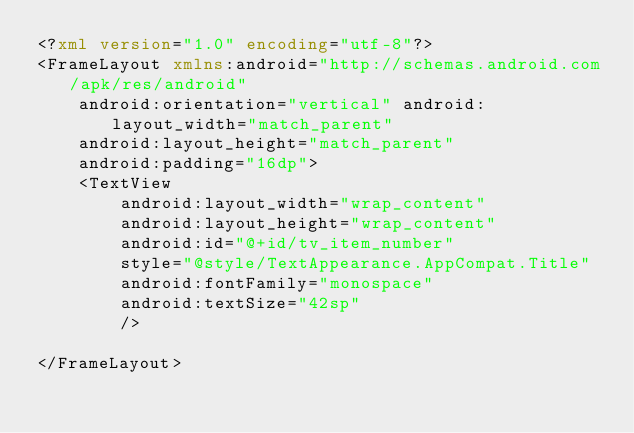<code> <loc_0><loc_0><loc_500><loc_500><_XML_><?xml version="1.0" encoding="utf-8"?>
<FrameLayout xmlns:android="http://schemas.android.com/apk/res/android"
    android:orientation="vertical" android:layout_width="match_parent"
    android:layout_height="match_parent"
    android:padding="16dp">
    <TextView
        android:layout_width="wrap_content"
        android:layout_height="wrap_content"
        android:id="@+id/tv_item_number"
        style="@style/TextAppearance.AppCompat.Title"
        android:fontFamily="monospace"
        android:textSize="42sp"
        />

</FrameLayout></code> 